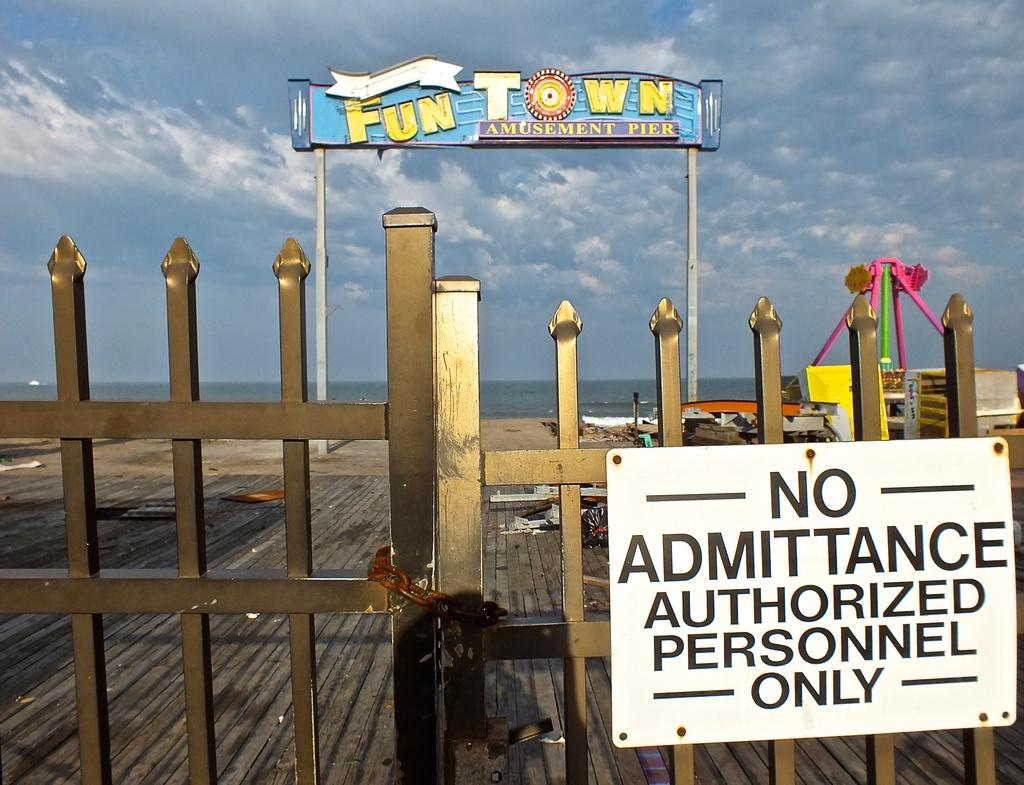<image>
Give a short and clear explanation of the subsequent image. A gate blocking the Fun Town amusement pier that states admittance is for authorized personnel only. 